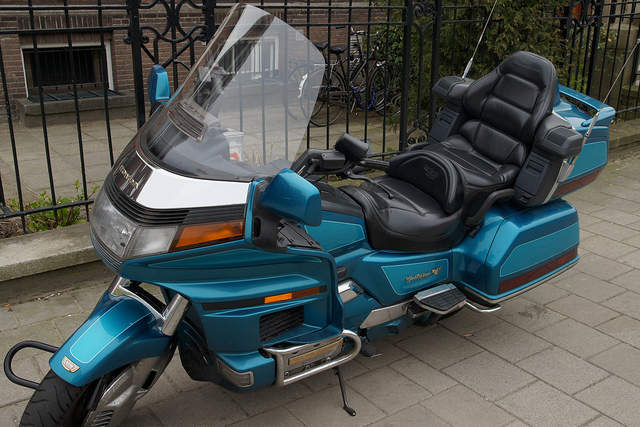How many people can ride this motorcycle at a time?
A. three
B. one
C. four
D. two Option D is correct. Although different motorcycles have varying capacities, this particular motorcycle appears designed for two people, with a dedicated seat for the driver and a pillion seat for a passenger. Both seats are equipped with backrests for comfort and safety during the ride. 